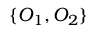<formula> <loc_0><loc_0><loc_500><loc_500>\{ O _ { 1 } , O _ { 2 } \}</formula> 